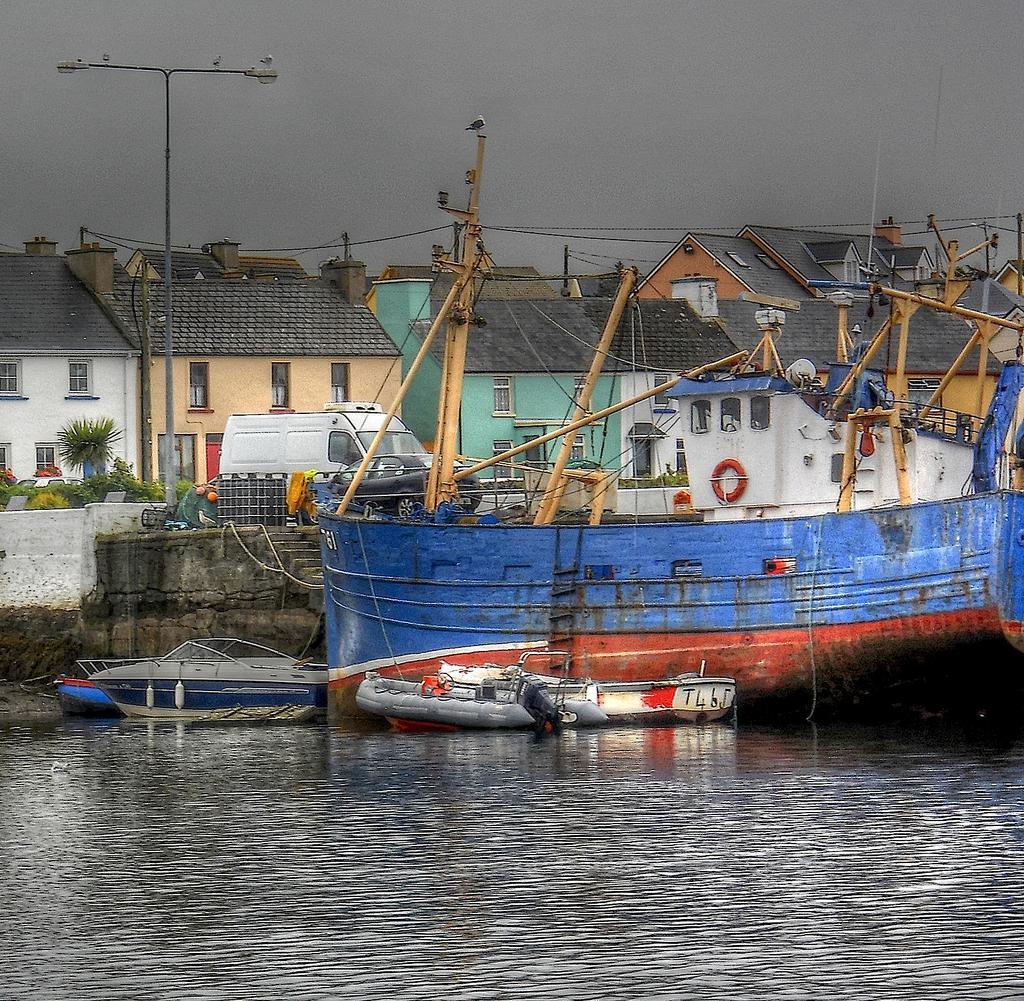Could you give a brief overview of what you see in this image? In this image there is water in which there are ships and small boats. In the background there are houses one beside the other. On the road there is a van and an electric pole. 